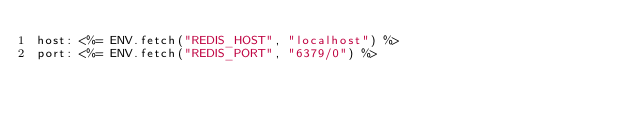<code> <loc_0><loc_0><loc_500><loc_500><_YAML_>host: <%= ENV.fetch("REDIS_HOST", "localhost") %>
port: <%= ENV.fetch("REDIS_PORT", "6379/0") %>
</code> 